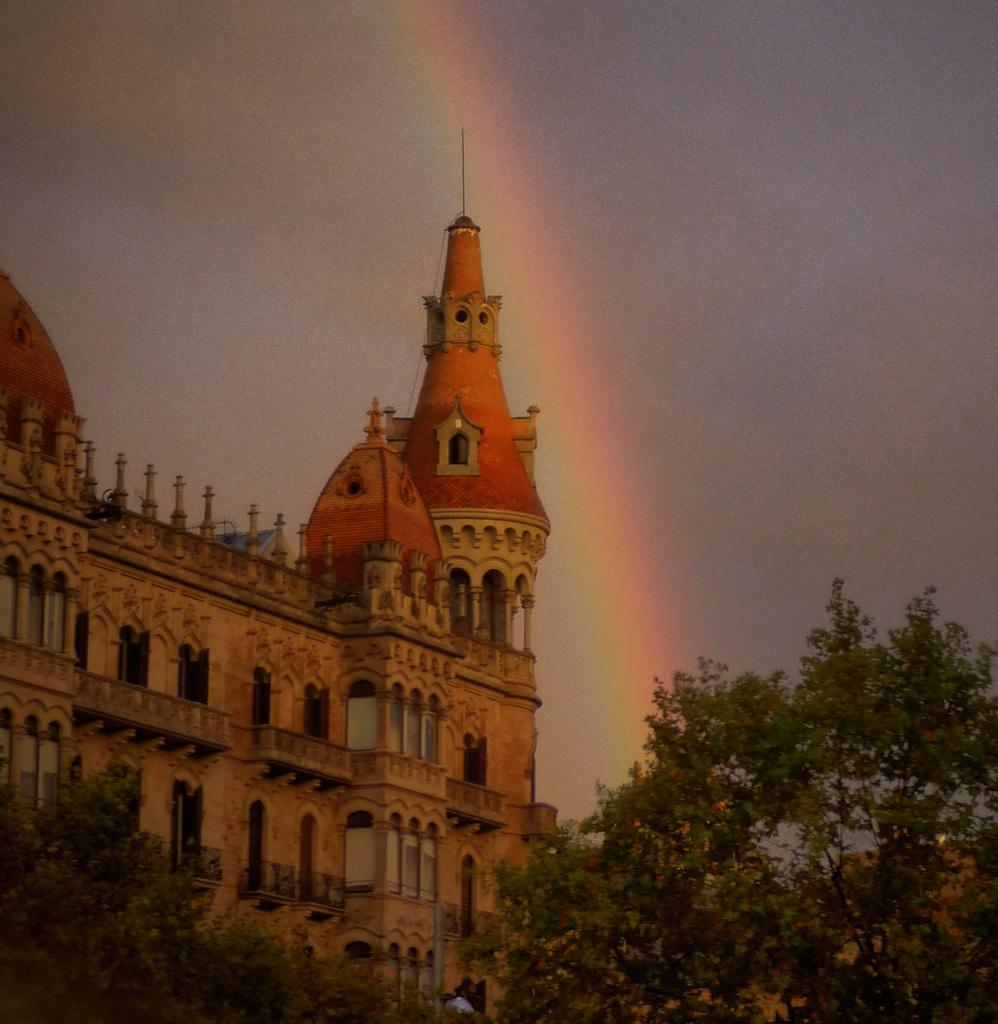What type of vegetation is at the bottom of the image? There are trees at the bottom of the image. What structure can be seen in the background of the image? There is a building in the background of the image. What feature is visible on the building in the image? There are windows visible in the image. What natural phenomenon can be seen in the sky? A rainbow is present in the sky. What else is visible in the sky besides the rainbow? Clouds are visible in the sky. What type of reaction does the tongue have to the stitch in the image? There is no tongue or stitch present in the image. What type of reaction does the rainbow have to the clouds in the image? The rainbow and clouds are separate natural phenomena in the sky and do not have a reaction to each other in the image. 